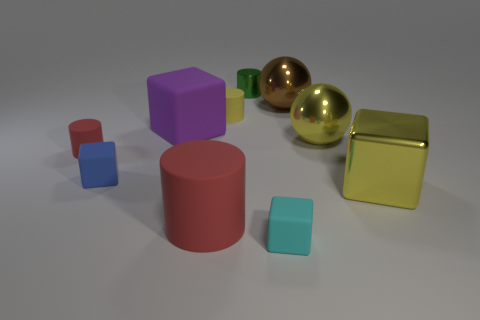The other cylinder that is the same color as the big matte cylinder is what size?
Give a very brief answer. Small. There is a large matte thing to the right of the big purple matte object; is its color the same as the object that is on the left side of the blue thing?
Your answer should be compact. Yes. What color is the rubber cube that is the same size as the metal cube?
Your answer should be very brief. Purple. How many other things are there of the same shape as the blue object?
Give a very brief answer. 3. What is the size of the cylinder behind the small yellow matte object?
Provide a short and direct response. Small. There is a big metallic thing that is behind the tiny yellow thing; what number of red things are in front of it?
Provide a succinct answer. 2. How many other things are there of the same size as the yellow sphere?
Make the answer very short. 4. Does the big cylinder have the same color as the shiny cylinder?
Offer a very short reply. No. There is a red thing right of the large purple thing; does it have the same shape as the small green thing?
Provide a succinct answer. Yes. What number of big objects are in front of the large brown shiny object and to the left of the yellow shiny cube?
Provide a short and direct response. 3. 